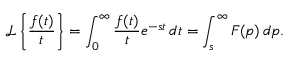<formula> <loc_0><loc_0><loc_500><loc_500>{ \mathcal { L } } \left \{ { \frac { f ( t ) } { t } } \right \} = \int _ { 0 } ^ { \infty } { \frac { f ( t ) } { t } } e ^ { - s t } \, d t = \int _ { s } ^ { \infty } F ( p ) \, d p .</formula> 